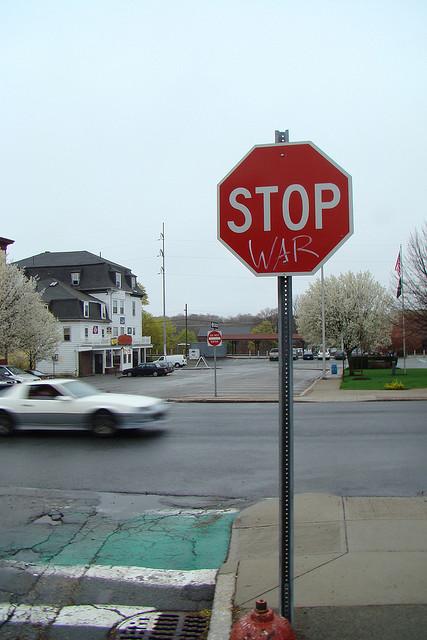What color is the street sign?
Write a very short answer. Red. Are there cars visible?
Concise answer only. Yes. What will be approaching on the sign?
Concise answer only. Car. What is the man walking on?
Concise answer only. Sidewalk. What does it say under the stop sign?
Short answer required. War. Is this free parking?
Concise answer only. No. How many cars are on the street?
Be succinct. 1. What color is the hydrant?
Be succinct. Red. What languages is this sign in?
Be succinct. English. How is traffic at this intersection?
Quick response, please. Slow. What does the sign say to stop?
Quick response, please. War. What does the red sign say?
Write a very short answer. Stop war. What does the sign say?
Write a very short answer. Stop war. Are the trees tall?
Quick response, please. No. What is in front of the stop sign?
Answer briefly. Fire hydrant. Are the cars moving?
Keep it brief. Yes. Does the street need to be fixed?
Be succinct. Yes. Do you see a bench in the photo?
Keep it brief. No. What is the weather?
Be succinct. Clear. Is the street empty?
Keep it brief. No. What language is on the sign?
Answer briefly. English. Is there a skyscraper?
Be succinct. No. Where is the silver car?
Be succinct. Road. How many different colors were used for all the graffiti?
Write a very short answer. 1. Is there a car on the street?
Answer briefly. Yes. Is there a flood?
Concise answer only. No. How many ways must stop?
Give a very brief answer. 1. What is the fire hydrant painted like?
Short answer required. Red. How many cars are in the picture?
Answer briefly. 1. What color is the sign?
Answer briefly. Red. Are all cars clearly in focus?
Quick response, please. No. IS the trunk open?
Write a very short answer. No. What song is the sign referencing?
Answer briefly. War. How many car's are there in the parking lot?
Give a very brief answer. 0. How many stop signs?
Concise answer only. 1. What sort of stop is this?
Short answer required. 4 way. Is there work being done?
Concise answer only. No. What color is the fire hydrant?
Be succinct. Red. 